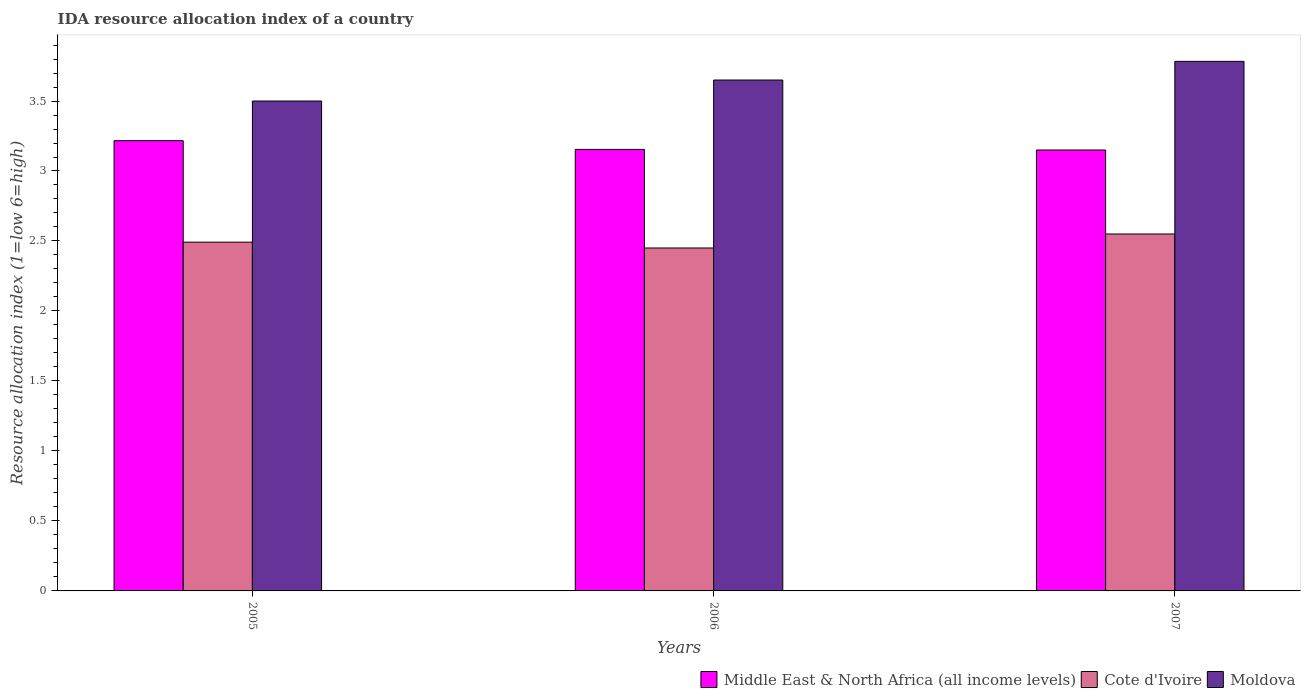How many different coloured bars are there?
Offer a terse response. 3. How many groups of bars are there?
Your answer should be compact. 3. Are the number of bars per tick equal to the number of legend labels?
Your answer should be compact. Yes. Are the number of bars on each tick of the X-axis equal?
Provide a short and direct response. Yes. In how many cases, is the number of bars for a given year not equal to the number of legend labels?
Provide a short and direct response. 0. What is the IDA resource allocation index in Cote d'Ivoire in 2007?
Provide a succinct answer. 2.55. Across all years, what is the maximum IDA resource allocation index in Moldova?
Make the answer very short. 3.78. Across all years, what is the minimum IDA resource allocation index in Moldova?
Your answer should be compact. 3.5. In which year was the IDA resource allocation index in Middle East & North Africa (all income levels) maximum?
Ensure brevity in your answer.  2005. In which year was the IDA resource allocation index in Middle East & North Africa (all income levels) minimum?
Keep it short and to the point. 2007. What is the total IDA resource allocation index in Cote d'Ivoire in the graph?
Provide a succinct answer. 7.49. What is the difference between the IDA resource allocation index in Cote d'Ivoire in 2005 and that in 2007?
Your answer should be very brief. -0.06. What is the difference between the IDA resource allocation index in Cote d'Ivoire in 2007 and the IDA resource allocation index in Moldova in 2005?
Offer a terse response. -0.95. What is the average IDA resource allocation index in Cote d'Ivoire per year?
Offer a very short reply. 2.5. In the year 2005, what is the difference between the IDA resource allocation index in Cote d'Ivoire and IDA resource allocation index in Moldova?
Offer a terse response. -1.01. In how many years, is the IDA resource allocation index in Cote d'Ivoire greater than 3.6?
Provide a short and direct response. 0. What is the ratio of the IDA resource allocation index in Moldova in 2005 to that in 2006?
Your answer should be compact. 0.96. What is the difference between the highest and the second highest IDA resource allocation index in Moldova?
Provide a succinct answer. 0.13. What is the difference between the highest and the lowest IDA resource allocation index in Moldova?
Offer a terse response. 0.28. In how many years, is the IDA resource allocation index in Moldova greater than the average IDA resource allocation index in Moldova taken over all years?
Give a very brief answer. 2. Is the sum of the IDA resource allocation index in Cote d'Ivoire in 2005 and 2006 greater than the maximum IDA resource allocation index in Moldova across all years?
Your answer should be very brief. Yes. What does the 3rd bar from the left in 2005 represents?
Offer a terse response. Moldova. What does the 3rd bar from the right in 2006 represents?
Your answer should be very brief. Middle East & North Africa (all income levels). Are all the bars in the graph horizontal?
Give a very brief answer. No. Are the values on the major ticks of Y-axis written in scientific E-notation?
Your answer should be compact. No. Does the graph contain any zero values?
Provide a succinct answer. No. Does the graph contain grids?
Your answer should be compact. No. Where does the legend appear in the graph?
Keep it short and to the point. Bottom right. How many legend labels are there?
Your answer should be very brief. 3. What is the title of the graph?
Provide a succinct answer. IDA resource allocation index of a country. What is the label or title of the Y-axis?
Your answer should be compact. Resource allocation index (1=low 6=high). What is the Resource allocation index (1=low 6=high) of Middle East & North Africa (all income levels) in 2005?
Give a very brief answer. 3.22. What is the Resource allocation index (1=low 6=high) in Cote d'Ivoire in 2005?
Give a very brief answer. 2.49. What is the Resource allocation index (1=low 6=high) in Moldova in 2005?
Provide a short and direct response. 3.5. What is the Resource allocation index (1=low 6=high) in Middle East & North Africa (all income levels) in 2006?
Your answer should be very brief. 3.15. What is the Resource allocation index (1=low 6=high) of Cote d'Ivoire in 2006?
Your answer should be compact. 2.45. What is the Resource allocation index (1=low 6=high) in Moldova in 2006?
Offer a terse response. 3.65. What is the Resource allocation index (1=low 6=high) of Middle East & North Africa (all income levels) in 2007?
Provide a succinct answer. 3.15. What is the Resource allocation index (1=low 6=high) in Cote d'Ivoire in 2007?
Provide a short and direct response. 2.55. What is the Resource allocation index (1=low 6=high) in Moldova in 2007?
Your answer should be compact. 3.78. Across all years, what is the maximum Resource allocation index (1=low 6=high) of Middle East & North Africa (all income levels)?
Your answer should be compact. 3.22. Across all years, what is the maximum Resource allocation index (1=low 6=high) of Cote d'Ivoire?
Provide a succinct answer. 2.55. Across all years, what is the maximum Resource allocation index (1=low 6=high) of Moldova?
Offer a terse response. 3.78. Across all years, what is the minimum Resource allocation index (1=low 6=high) of Middle East & North Africa (all income levels)?
Offer a terse response. 3.15. Across all years, what is the minimum Resource allocation index (1=low 6=high) of Cote d'Ivoire?
Provide a succinct answer. 2.45. Across all years, what is the minimum Resource allocation index (1=low 6=high) in Moldova?
Provide a succinct answer. 3.5. What is the total Resource allocation index (1=low 6=high) of Middle East & North Africa (all income levels) in the graph?
Provide a succinct answer. 9.52. What is the total Resource allocation index (1=low 6=high) of Cote d'Ivoire in the graph?
Your response must be concise. 7.49. What is the total Resource allocation index (1=low 6=high) of Moldova in the graph?
Your answer should be compact. 10.93. What is the difference between the Resource allocation index (1=low 6=high) in Middle East & North Africa (all income levels) in 2005 and that in 2006?
Provide a short and direct response. 0.06. What is the difference between the Resource allocation index (1=low 6=high) in Cote d'Ivoire in 2005 and that in 2006?
Ensure brevity in your answer.  0.04. What is the difference between the Resource allocation index (1=low 6=high) of Moldova in 2005 and that in 2006?
Ensure brevity in your answer.  -0.15. What is the difference between the Resource allocation index (1=low 6=high) in Middle East & North Africa (all income levels) in 2005 and that in 2007?
Keep it short and to the point. 0.07. What is the difference between the Resource allocation index (1=low 6=high) in Cote d'Ivoire in 2005 and that in 2007?
Make the answer very short. -0.06. What is the difference between the Resource allocation index (1=low 6=high) of Moldova in 2005 and that in 2007?
Your answer should be very brief. -0.28. What is the difference between the Resource allocation index (1=low 6=high) in Middle East & North Africa (all income levels) in 2006 and that in 2007?
Your answer should be very brief. 0. What is the difference between the Resource allocation index (1=low 6=high) of Cote d'Ivoire in 2006 and that in 2007?
Ensure brevity in your answer.  -0.1. What is the difference between the Resource allocation index (1=low 6=high) of Moldova in 2006 and that in 2007?
Your answer should be very brief. -0.13. What is the difference between the Resource allocation index (1=low 6=high) in Middle East & North Africa (all income levels) in 2005 and the Resource allocation index (1=low 6=high) in Cote d'Ivoire in 2006?
Keep it short and to the point. 0.77. What is the difference between the Resource allocation index (1=low 6=high) of Middle East & North Africa (all income levels) in 2005 and the Resource allocation index (1=low 6=high) of Moldova in 2006?
Give a very brief answer. -0.43. What is the difference between the Resource allocation index (1=low 6=high) of Cote d'Ivoire in 2005 and the Resource allocation index (1=low 6=high) of Moldova in 2006?
Your answer should be very brief. -1.16. What is the difference between the Resource allocation index (1=low 6=high) in Middle East & North Africa (all income levels) in 2005 and the Resource allocation index (1=low 6=high) in Cote d'Ivoire in 2007?
Your response must be concise. 0.67. What is the difference between the Resource allocation index (1=low 6=high) in Middle East & North Africa (all income levels) in 2005 and the Resource allocation index (1=low 6=high) in Moldova in 2007?
Your answer should be very brief. -0.57. What is the difference between the Resource allocation index (1=low 6=high) of Cote d'Ivoire in 2005 and the Resource allocation index (1=low 6=high) of Moldova in 2007?
Offer a terse response. -1.29. What is the difference between the Resource allocation index (1=low 6=high) in Middle East & North Africa (all income levels) in 2006 and the Resource allocation index (1=low 6=high) in Cote d'Ivoire in 2007?
Your response must be concise. 0.6. What is the difference between the Resource allocation index (1=low 6=high) of Middle East & North Africa (all income levels) in 2006 and the Resource allocation index (1=low 6=high) of Moldova in 2007?
Make the answer very short. -0.63. What is the difference between the Resource allocation index (1=low 6=high) of Cote d'Ivoire in 2006 and the Resource allocation index (1=low 6=high) of Moldova in 2007?
Your answer should be compact. -1.33. What is the average Resource allocation index (1=low 6=high) of Middle East & North Africa (all income levels) per year?
Your answer should be compact. 3.17. What is the average Resource allocation index (1=low 6=high) in Cote d'Ivoire per year?
Provide a short and direct response. 2.5. What is the average Resource allocation index (1=low 6=high) of Moldova per year?
Offer a terse response. 3.64. In the year 2005, what is the difference between the Resource allocation index (1=low 6=high) of Middle East & North Africa (all income levels) and Resource allocation index (1=low 6=high) of Cote d'Ivoire?
Keep it short and to the point. 0.72. In the year 2005, what is the difference between the Resource allocation index (1=low 6=high) in Middle East & North Africa (all income levels) and Resource allocation index (1=low 6=high) in Moldova?
Make the answer very short. -0.28. In the year 2005, what is the difference between the Resource allocation index (1=low 6=high) of Cote d'Ivoire and Resource allocation index (1=low 6=high) of Moldova?
Provide a succinct answer. -1.01. In the year 2006, what is the difference between the Resource allocation index (1=low 6=high) in Middle East & North Africa (all income levels) and Resource allocation index (1=low 6=high) in Cote d'Ivoire?
Keep it short and to the point. 0.7. In the year 2006, what is the difference between the Resource allocation index (1=low 6=high) of Middle East & North Africa (all income levels) and Resource allocation index (1=low 6=high) of Moldova?
Keep it short and to the point. -0.5. In the year 2006, what is the difference between the Resource allocation index (1=low 6=high) in Cote d'Ivoire and Resource allocation index (1=low 6=high) in Moldova?
Offer a terse response. -1.2. In the year 2007, what is the difference between the Resource allocation index (1=low 6=high) in Middle East & North Africa (all income levels) and Resource allocation index (1=low 6=high) in Moldova?
Your response must be concise. -0.63. In the year 2007, what is the difference between the Resource allocation index (1=low 6=high) of Cote d'Ivoire and Resource allocation index (1=low 6=high) of Moldova?
Ensure brevity in your answer.  -1.23. What is the ratio of the Resource allocation index (1=low 6=high) in Middle East & North Africa (all income levels) in 2005 to that in 2006?
Your answer should be compact. 1.02. What is the ratio of the Resource allocation index (1=low 6=high) in Moldova in 2005 to that in 2006?
Keep it short and to the point. 0.96. What is the ratio of the Resource allocation index (1=low 6=high) of Middle East & North Africa (all income levels) in 2005 to that in 2007?
Your answer should be compact. 1.02. What is the ratio of the Resource allocation index (1=low 6=high) in Cote d'Ivoire in 2005 to that in 2007?
Make the answer very short. 0.98. What is the ratio of the Resource allocation index (1=low 6=high) in Moldova in 2005 to that in 2007?
Provide a succinct answer. 0.93. What is the ratio of the Resource allocation index (1=low 6=high) of Middle East & North Africa (all income levels) in 2006 to that in 2007?
Provide a succinct answer. 1. What is the ratio of the Resource allocation index (1=low 6=high) in Cote d'Ivoire in 2006 to that in 2007?
Provide a short and direct response. 0.96. What is the ratio of the Resource allocation index (1=low 6=high) of Moldova in 2006 to that in 2007?
Provide a succinct answer. 0.96. What is the difference between the highest and the second highest Resource allocation index (1=low 6=high) in Middle East & North Africa (all income levels)?
Ensure brevity in your answer.  0.06. What is the difference between the highest and the second highest Resource allocation index (1=low 6=high) of Cote d'Ivoire?
Provide a short and direct response. 0.06. What is the difference between the highest and the second highest Resource allocation index (1=low 6=high) in Moldova?
Give a very brief answer. 0.13. What is the difference between the highest and the lowest Resource allocation index (1=low 6=high) in Middle East & North Africa (all income levels)?
Offer a very short reply. 0.07. What is the difference between the highest and the lowest Resource allocation index (1=low 6=high) of Cote d'Ivoire?
Your answer should be compact. 0.1. What is the difference between the highest and the lowest Resource allocation index (1=low 6=high) in Moldova?
Your response must be concise. 0.28. 